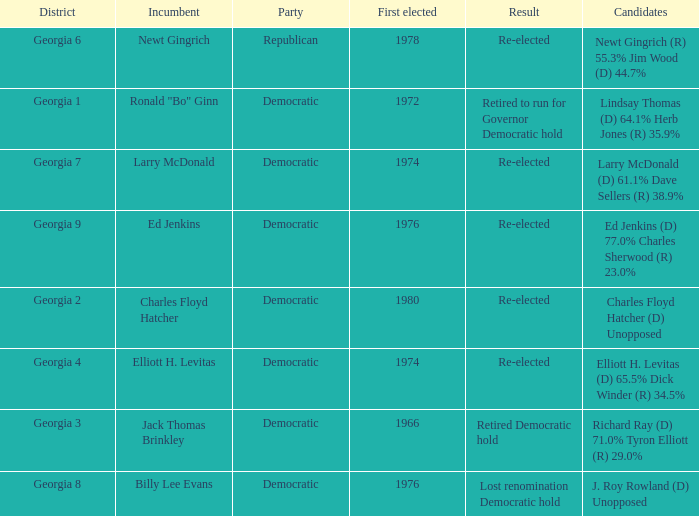Name the districk for larry mcdonald Georgia 7. 